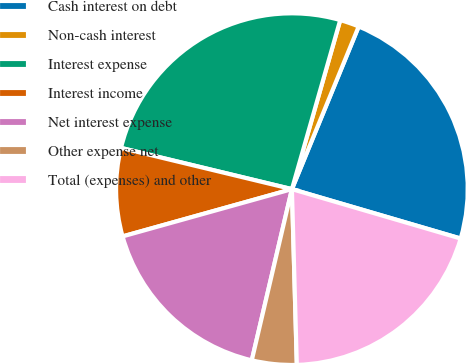Convert chart to OTSL. <chart><loc_0><loc_0><loc_500><loc_500><pie_chart><fcel>Cash interest on debt<fcel>Non-cash interest<fcel>Interest expense<fcel>Interest income<fcel>Net interest expense<fcel>Other expense net<fcel>Total (expenses) and other<nl><fcel>23.33%<fcel>1.77%<fcel>25.66%<fcel>8.1%<fcel>17.0%<fcel>4.11%<fcel>20.02%<nl></chart> 